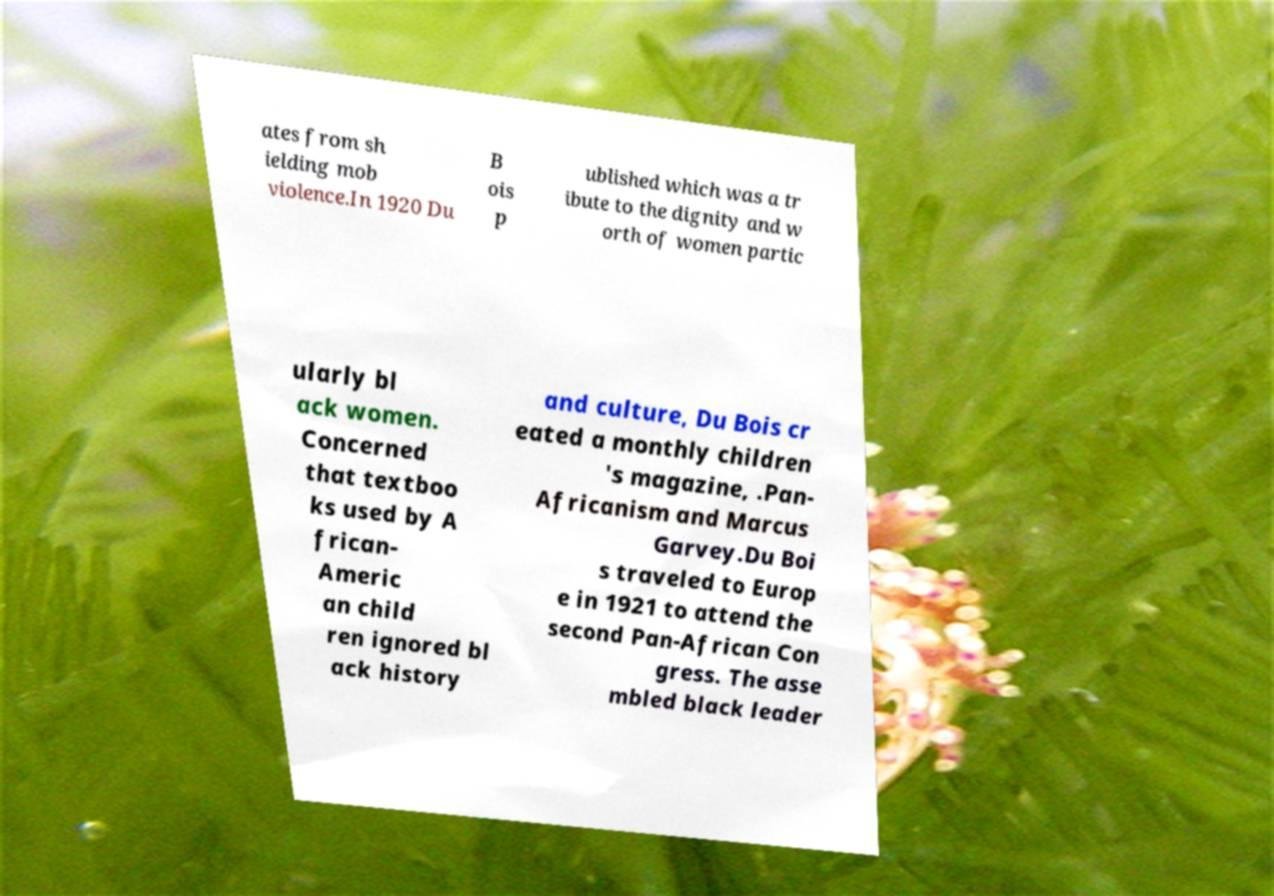For documentation purposes, I need the text within this image transcribed. Could you provide that? ates from sh ielding mob violence.In 1920 Du B ois p ublished which was a tr ibute to the dignity and w orth of women partic ularly bl ack women. Concerned that textboo ks used by A frican- Americ an child ren ignored bl ack history and culture, Du Bois cr eated a monthly children 's magazine, .Pan- Africanism and Marcus Garvey.Du Boi s traveled to Europ e in 1921 to attend the second Pan-African Con gress. The asse mbled black leader 